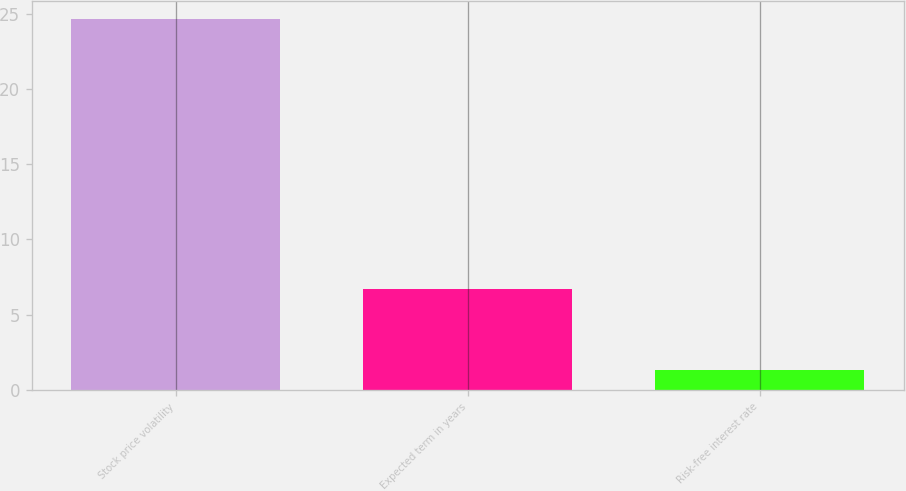Convert chart. <chart><loc_0><loc_0><loc_500><loc_500><bar_chart><fcel>Stock price volatility<fcel>Expected term in years<fcel>Risk-free interest rate<nl><fcel>24.61<fcel>6.69<fcel>1.31<nl></chart> 